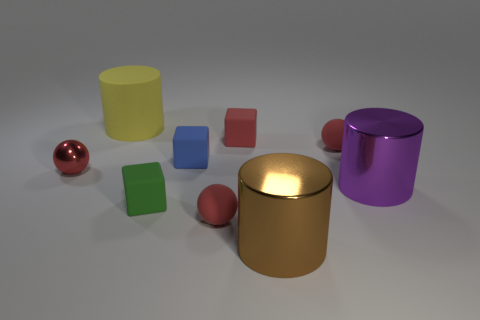How many red balls must be subtracted to get 1 red balls? 2 Subtract all tiny rubber spheres. How many spheres are left? 1 Subtract 1 spheres. How many spheres are left? 2 Subtract all green cubes. How many cubes are left? 2 Subtract all cubes. How many objects are left? 6 Subtract all yellow blocks. Subtract all gray balls. How many blocks are left? 3 Subtract all large brown matte cylinders. Subtract all small metallic spheres. How many objects are left? 8 Add 4 tiny red rubber things. How many tiny red rubber things are left? 7 Add 1 small red metallic things. How many small red metallic things exist? 2 Subtract 1 red blocks. How many objects are left? 8 